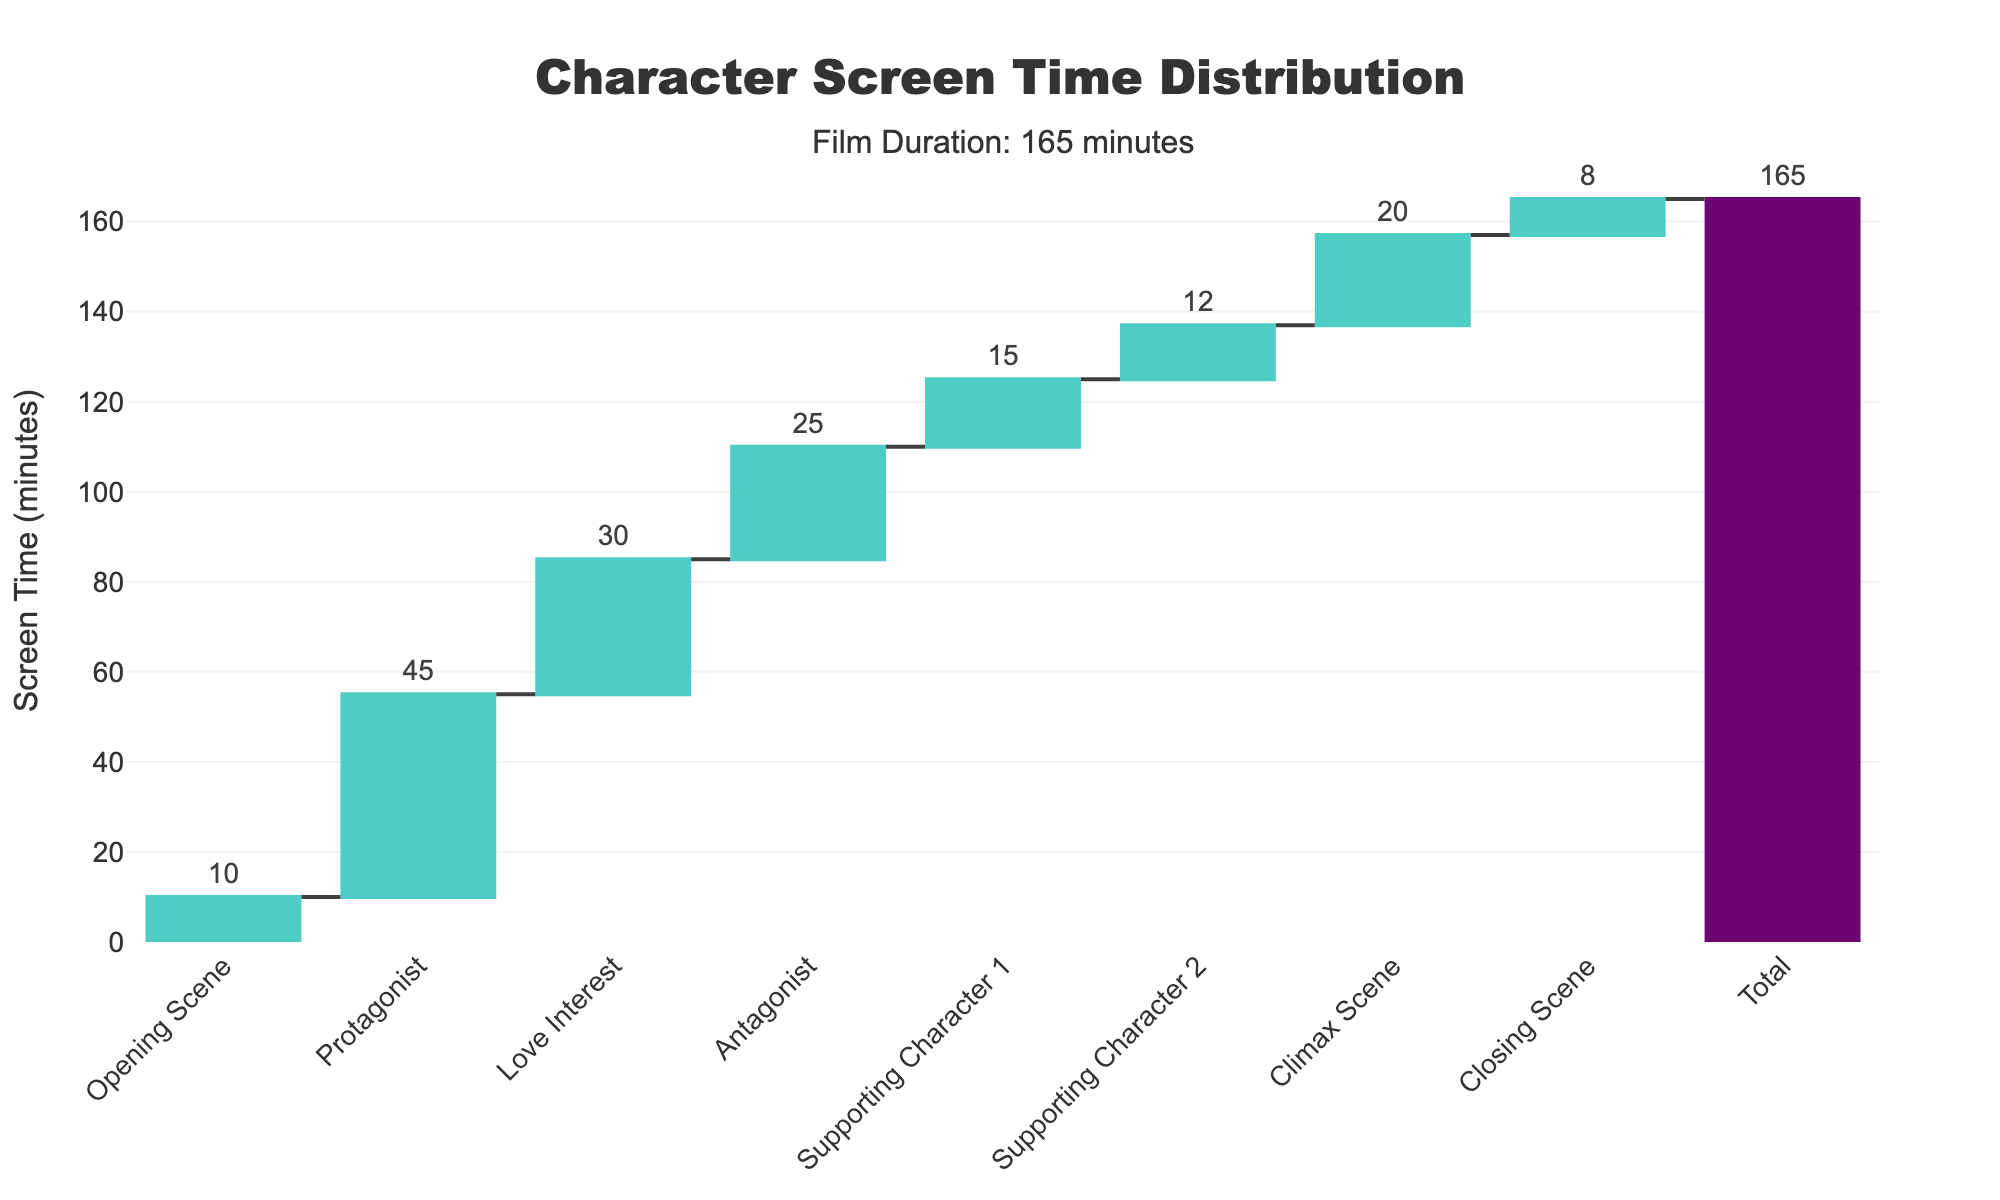What's the title of the figure? The title is located at the top center of the figure and reads "Character Screen Time Distribution".
Answer: Character Screen Time Distribution How long is the film according to the figure? The figure includes an annotation that mentions "Film Duration: 165 minutes", indicating the total runtime.
Answer: 165 minutes Which character has the most screen time? Referring to the figure, the Protagonist has the highest numerical value associated with screen time.
Answer: Protagonist What is the total screen time of all supporting characters combined? The respective screen times of Supporting Character 1 and Supporting Character 2 are 15 and 12 minutes respectively. Adding these gives 15 + 12 = 27 minutes.
Answer: 27 minutes Which character appears less: the Antagonist or the Love Interest? By comparing the heights of the bars for the Antagonist and the Love Interest, the Love Interest has more screen time (30 minutes) compared to the Antagonist (25 minutes).
Answer: Antagonist What percentage of the total film length is the Climax Scene? The Climax Scene's screen time is 20 minutes. To find the percentage, divide it by the total film length: (20 / 165) * 100 ≈ 12.12%.
Answer: 12.12% How does the total screen time of the Opening Scene and Closing Scene compare? The Opening Scene has 10 minutes of screen time and the Closing Scene has 8 minutes of screen time. To compare them: 10 - 8 = 2 minutes more for the Opening Scene.
Answer: 2 minutes more for Opening Scene How much more screen time does the Protagonist have than the Supporting Character 1? The Protagonist has 45 minutes of screen time, while Supporting Character 1 has 15 minutes. The difference is 45 - 15 = 30 minutes.
Answer: 30 minutes What is the average screen time of the listed scenes (Opening Scene, Climax Scene, and Closing Scene)? The screen times for the Opening Scene, Climax Scene, and Closing Scene are 10, 20, and 8 minutes respectively. Summing them gives 38 minutes, and dividing by the 3 scenes gives an average: 38 / 3 ≈ 12.67 minutes.
Answer: 12.67 minutes In terms of screen time, who spends almost half the time as the Protagonist? The Protagonist has 45 minutes. Half of this time is 22.5 minutes. The closest screen time value is that of the Antagonist, who has 25 minutes.
Answer: Antagonist 